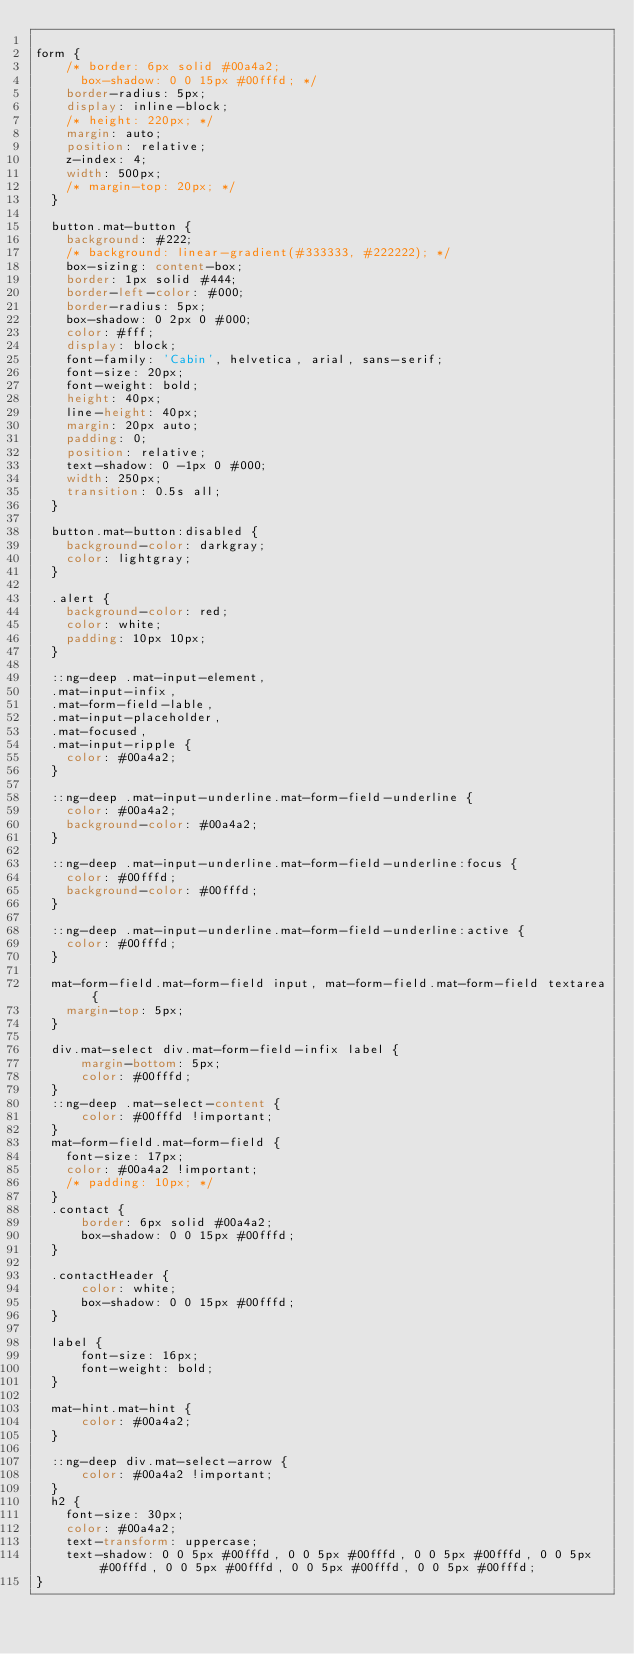Convert code to text. <code><loc_0><loc_0><loc_500><loc_500><_CSS_>
form {
    /* border: 6px solid #00a4a2;
      box-shadow: 0 0 15px #00fffd; */
    border-radius: 5px;
    display: inline-block;
    /* height: 220px; */
    margin: auto;
    position: relative;
    z-index: 4;
    width: 500px;
    /* margin-top: 20px; */
  }
  
  button.mat-button {
    background: #222;
    /* background: linear-gradient(#333333, #222222); */
    box-sizing: content-box;
    border: 1px solid #444;
    border-left-color: #000;
    border-radius: 5px;
    box-shadow: 0 2px 0 #000;
    color: #fff;
    display: block;
    font-family: 'Cabin', helvetica, arial, sans-serif;
    font-size: 20px;
    font-weight: bold;
    height: 40px;
    line-height: 40px;
    margin: 20px auto;
    padding: 0;
    position: relative;
    text-shadow: 0 -1px 0 #000;
    width: 250px;
    transition: 0.5s all;
  }
  
  button.mat-button:disabled {
    background-color: darkgray;
    color: lightgray;
  }
  
  .alert {
    background-color: red;
    color: white;
    padding: 10px 10px;
  }
  
  ::ng-deep .mat-input-element,
  .mat-input-infix,
  .mat-form-field-lable,
  .mat-input-placeholder,
  .mat-focused,
  .mat-input-ripple {
    color: #00a4a2;
  }
  
  ::ng-deep .mat-input-underline.mat-form-field-underline {
    color: #00a4a2;
    background-color: #00a4a2;
  }
  
  ::ng-deep .mat-input-underline.mat-form-field-underline:focus {
    color: #00fffd;
    background-color: #00fffd;
  }
  
  ::ng-deep .mat-input-underline.mat-form-field-underline:active {
    color: #00fffd;
  }
  
  mat-form-field.mat-form-field input, mat-form-field.mat-form-field textarea {
    margin-top: 5px;
  }
  
  div.mat-select div.mat-form-field-infix label {
      margin-bottom: 5px;
      color: #00fffd;
  }
  ::ng-deep .mat-select-content {
      color: #00fffd !important;
  }
  mat-form-field.mat-form-field {
    font-size: 17px;
    color: #00a4a2 !important;
    /* padding: 10px; */
  }
  .contact {
      border: 6px solid #00a4a2;
      box-shadow: 0 0 15px #00fffd;
  }
  
  .contactHeader {
      color: white;
      box-shadow: 0 0 15px #00fffd;
  }
  
  label {
      font-size: 16px;
      font-weight: bold;
  }
  
  mat-hint.mat-hint {
      color: #00a4a2;
  }
  
  ::ng-deep div.mat-select-arrow {
      color: #00a4a2 !important;
  }
  h2 {
    font-size: 30px;
    color: #00a4a2;
    text-transform: uppercase;
    text-shadow: 0 0 5px #00fffd, 0 0 5px #00fffd, 0 0 5px #00fffd, 0 0 5px #00fffd, 0 0 5px #00fffd, 0 0 5px #00fffd, 0 0 5px #00fffd;
}</code> 